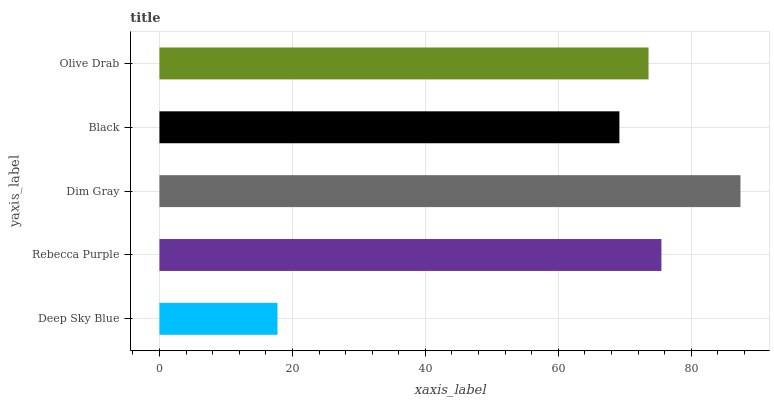Is Deep Sky Blue the minimum?
Answer yes or no. Yes. Is Dim Gray the maximum?
Answer yes or no. Yes. Is Rebecca Purple the minimum?
Answer yes or no. No. Is Rebecca Purple the maximum?
Answer yes or no. No. Is Rebecca Purple greater than Deep Sky Blue?
Answer yes or no. Yes. Is Deep Sky Blue less than Rebecca Purple?
Answer yes or no. Yes. Is Deep Sky Blue greater than Rebecca Purple?
Answer yes or no. No. Is Rebecca Purple less than Deep Sky Blue?
Answer yes or no. No. Is Olive Drab the high median?
Answer yes or no. Yes. Is Olive Drab the low median?
Answer yes or no. Yes. Is Dim Gray the high median?
Answer yes or no. No. Is Dim Gray the low median?
Answer yes or no. No. 